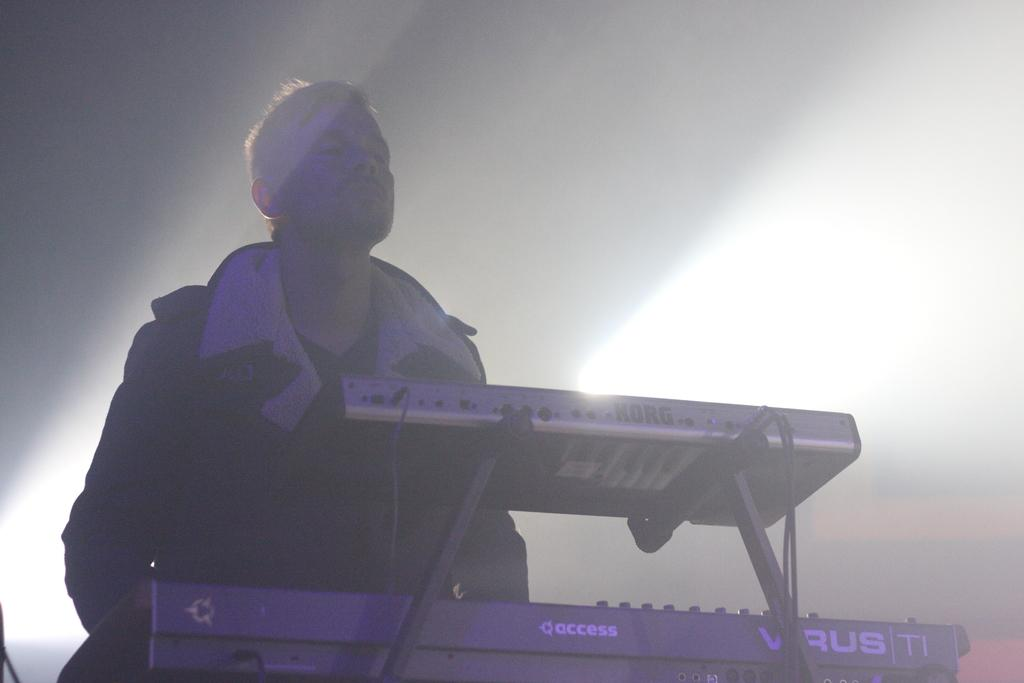Who is present in the image? There is a person in the image. What is the person wearing? The person is wearing a coat. What else can be seen in the image besides the person? There are musical instruments in the image. What is the color of the surface in the background of the image? There is a white surface in the background of the image. How many things can be heard laughing in the image? There are no audible sounds or laughter in the image, as it is a still photograph. 